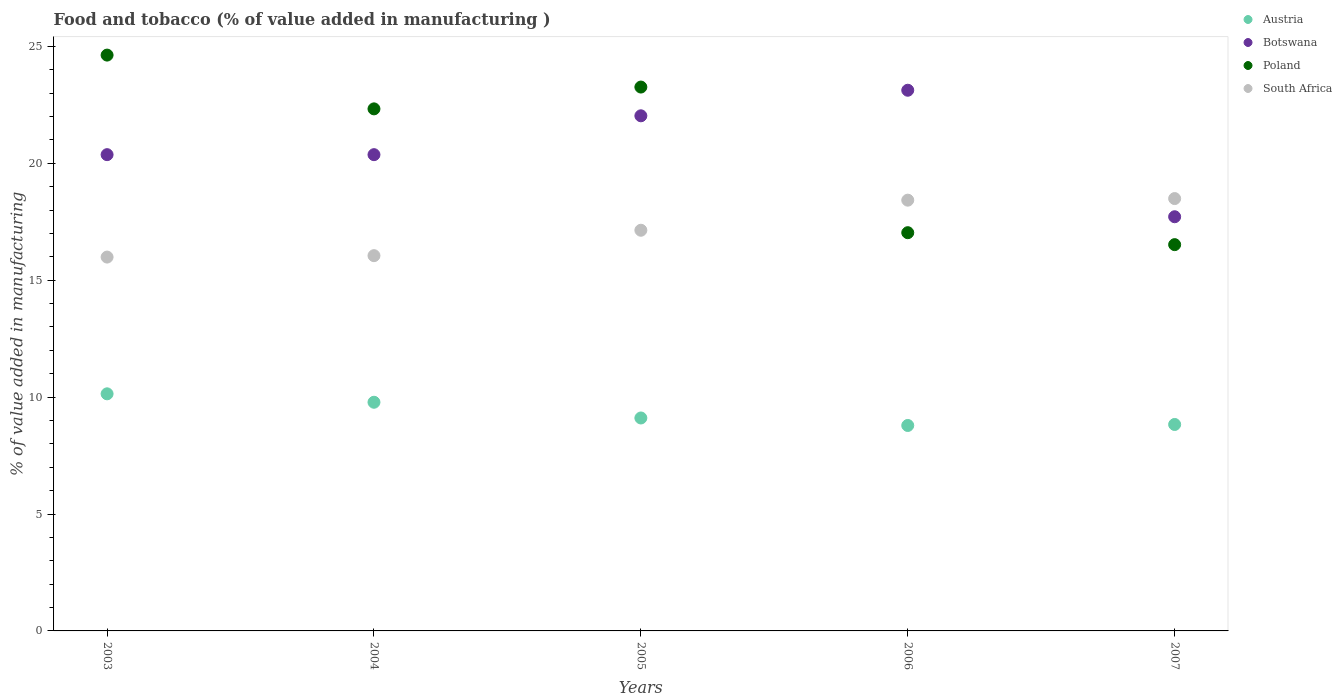How many different coloured dotlines are there?
Make the answer very short. 4. Is the number of dotlines equal to the number of legend labels?
Provide a succinct answer. Yes. What is the value added in manufacturing food and tobacco in Austria in 2004?
Provide a succinct answer. 9.78. Across all years, what is the maximum value added in manufacturing food and tobacco in Austria?
Your answer should be very brief. 10.14. Across all years, what is the minimum value added in manufacturing food and tobacco in Austria?
Keep it short and to the point. 8.79. In which year was the value added in manufacturing food and tobacco in Botswana maximum?
Offer a very short reply. 2006. What is the total value added in manufacturing food and tobacco in Botswana in the graph?
Provide a short and direct response. 103.61. What is the difference between the value added in manufacturing food and tobacco in Botswana in 2004 and that in 2007?
Your answer should be very brief. 2.66. What is the difference between the value added in manufacturing food and tobacco in Poland in 2006 and the value added in manufacturing food and tobacco in South Africa in 2007?
Make the answer very short. -1.46. What is the average value added in manufacturing food and tobacco in Austria per year?
Offer a very short reply. 9.33. In the year 2005, what is the difference between the value added in manufacturing food and tobacco in South Africa and value added in manufacturing food and tobacco in Austria?
Your response must be concise. 8.03. In how many years, is the value added in manufacturing food and tobacco in Austria greater than 15 %?
Provide a succinct answer. 0. What is the ratio of the value added in manufacturing food and tobacco in Austria in 2005 to that in 2006?
Provide a succinct answer. 1.04. Is the value added in manufacturing food and tobacco in Poland in 2006 less than that in 2007?
Give a very brief answer. No. Is the difference between the value added in manufacturing food and tobacco in South Africa in 2004 and 2005 greater than the difference between the value added in manufacturing food and tobacco in Austria in 2004 and 2005?
Ensure brevity in your answer.  No. What is the difference between the highest and the second highest value added in manufacturing food and tobacco in Poland?
Offer a terse response. 1.37. What is the difference between the highest and the lowest value added in manufacturing food and tobacco in South Africa?
Your answer should be very brief. 2.5. Is the sum of the value added in manufacturing food and tobacco in Botswana in 2005 and 2007 greater than the maximum value added in manufacturing food and tobacco in South Africa across all years?
Give a very brief answer. Yes. Is it the case that in every year, the sum of the value added in manufacturing food and tobacco in Botswana and value added in manufacturing food and tobacco in Austria  is greater than the value added in manufacturing food and tobacco in Poland?
Offer a very short reply. Yes. Does the value added in manufacturing food and tobacco in Poland monotonically increase over the years?
Offer a terse response. No. Is the value added in manufacturing food and tobacco in Botswana strictly greater than the value added in manufacturing food and tobacco in Poland over the years?
Provide a succinct answer. No. How many dotlines are there?
Provide a short and direct response. 4. How many years are there in the graph?
Your answer should be very brief. 5. What is the difference between two consecutive major ticks on the Y-axis?
Make the answer very short. 5. Does the graph contain any zero values?
Offer a terse response. No. Does the graph contain grids?
Ensure brevity in your answer.  No. Where does the legend appear in the graph?
Keep it short and to the point. Top right. How many legend labels are there?
Your answer should be compact. 4. What is the title of the graph?
Provide a succinct answer. Food and tobacco (% of value added in manufacturing ). Does "Equatorial Guinea" appear as one of the legend labels in the graph?
Your response must be concise. No. What is the label or title of the Y-axis?
Provide a succinct answer. % of value added in manufacturing. What is the % of value added in manufacturing in Austria in 2003?
Your answer should be very brief. 10.14. What is the % of value added in manufacturing of Botswana in 2003?
Ensure brevity in your answer.  20.37. What is the % of value added in manufacturing of Poland in 2003?
Make the answer very short. 24.63. What is the % of value added in manufacturing of South Africa in 2003?
Provide a succinct answer. 15.99. What is the % of value added in manufacturing in Austria in 2004?
Offer a terse response. 9.78. What is the % of value added in manufacturing in Botswana in 2004?
Your answer should be compact. 20.37. What is the % of value added in manufacturing in Poland in 2004?
Offer a very short reply. 22.33. What is the % of value added in manufacturing in South Africa in 2004?
Ensure brevity in your answer.  16.05. What is the % of value added in manufacturing in Austria in 2005?
Offer a terse response. 9.11. What is the % of value added in manufacturing in Botswana in 2005?
Offer a very short reply. 22.03. What is the % of value added in manufacturing of Poland in 2005?
Your answer should be very brief. 23.26. What is the % of value added in manufacturing in South Africa in 2005?
Make the answer very short. 17.14. What is the % of value added in manufacturing of Austria in 2006?
Your answer should be compact. 8.79. What is the % of value added in manufacturing of Botswana in 2006?
Offer a terse response. 23.13. What is the % of value added in manufacturing in Poland in 2006?
Offer a very short reply. 17.03. What is the % of value added in manufacturing in South Africa in 2006?
Provide a succinct answer. 18.42. What is the % of value added in manufacturing in Austria in 2007?
Provide a succinct answer. 8.83. What is the % of value added in manufacturing in Botswana in 2007?
Offer a very short reply. 17.72. What is the % of value added in manufacturing in Poland in 2007?
Offer a terse response. 16.52. What is the % of value added in manufacturing of South Africa in 2007?
Your answer should be compact. 18.49. Across all years, what is the maximum % of value added in manufacturing of Austria?
Keep it short and to the point. 10.14. Across all years, what is the maximum % of value added in manufacturing in Botswana?
Offer a terse response. 23.13. Across all years, what is the maximum % of value added in manufacturing of Poland?
Your response must be concise. 24.63. Across all years, what is the maximum % of value added in manufacturing of South Africa?
Your response must be concise. 18.49. Across all years, what is the minimum % of value added in manufacturing of Austria?
Keep it short and to the point. 8.79. Across all years, what is the minimum % of value added in manufacturing of Botswana?
Keep it short and to the point. 17.72. Across all years, what is the minimum % of value added in manufacturing in Poland?
Offer a terse response. 16.52. Across all years, what is the minimum % of value added in manufacturing in South Africa?
Provide a succinct answer. 15.99. What is the total % of value added in manufacturing in Austria in the graph?
Keep it short and to the point. 46.65. What is the total % of value added in manufacturing of Botswana in the graph?
Ensure brevity in your answer.  103.61. What is the total % of value added in manufacturing of Poland in the graph?
Give a very brief answer. 103.78. What is the total % of value added in manufacturing of South Africa in the graph?
Provide a succinct answer. 86.09. What is the difference between the % of value added in manufacturing in Austria in 2003 and that in 2004?
Provide a short and direct response. 0.36. What is the difference between the % of value added in manufacturing in Botswana in 2003 and that in 2004?
Give a very brief answer. 0. What is the difference between the % of value added in manufacturing in South Africa in 2003 and that in 2004?
Keep it short and to the point. -0.06. What is the difference between the % of value added in manufacturing in Austria in 2003 and that in 2005?
Your answer should be very brief. 1.03. What is the difference between the % of value added in manufacturing of Botswana in 2003 and that in 2005?
Provide a short and direct response. -1.66. What is the difference between the % of value added in manufacturing of Poland in 2003 and that in 2005?
Keep it short and to the point. 1.37. What is the difference between the % of value added in manufacturing of South Africa in 2003 and that in 2005?
Your response must be concise. -1.15. What is the difference between the % of value added in manufacturing in Austria in 2003 and that in 2006?
Your answer should be very brief. 1.35. What is the difference between the % of value added in manufacturing in Botswana in 2003 and that in 2006?
Give a very brief answer. -2.76. What is the difference between the % of value added in manufacturing in Poland in 2003 and that in 2006?
Your answer should be compact. 7.6. What is the difference between the % of value added in manufacturing in South Africa in 2003 and that in 2006?
Your answer should be very brief. -2.43. What is the difference between the % of value added in manufacturing in Austria in 2003 and that in 2007?
Your answer should be very brief. 1.31. What is the difference between the % of value added in manufacturing in Botswana in 2003 and that in 2007?
Your response must be concise. 2.66. What is the difference between the % of value added in manufacturing of Poland in 2003 and that in 2007?
Your answer should be very brief. 8.11. What is the difference between the % of value added in manufacturing in South Africa in 2003 and that in 2007?
Your response must be concise. -2.5. What is the difference between the % of value added in manufacturing of Austria in 2004 and that in 2005?
Provide a succinct answer. 0.67. What is the difference between the % of value added in manufacturing of Botswana in 2004 and that in 2005?
Your response must be concise. -1.66. What is the difference between the % of value added in manufacturing in Poland in 2004 and that in 2005?
Your response must be concise. -0.93. What is the difference between the % of value added in manufacturing in South Africa in 2004 and that in 2005?
Offer a very short reply. -1.09. What is the difference between the % of value added in manufacturing of Botswana in 2004 and that in 2006?
Your answer should be compact. -2.76. What is the difference between the % of value added in manufacturing of Poland in 2004 and that in 2006?
Offer a terse response. 5.3. What is the difference between the % of value added in manufacturing in South Africa in 2004 and that in 2006?
Provide a succinct answer. -2.37. What is the difference between the % of value added in manufacturing of Austria in 2004 and that in 2007?
Offer a terse response. 0.95. What is the difference between the % of value added in manufacturing in Botswana in 2004 and that in 2007?
Give a very brief answer. 2.66. What is the difference between the % of value added in manufacturing in Poland in 2004 and that in 2007?
Provide a short and direct response. 5.81. What is the difference between the % of value added in manufacturing of South Africa in 2004 and that in 2007?
Give a very brief answer. -2.44. What is the difference between the % of value added in manufacturing of Austria in 2005 and that in 2006?
Offer a terse response. 0.32. What is the difference between the % of value added in manufacturing in Botswana in 2005 and that in 2006?
Provide a succinct answer. -1.09. What is the difference between the % of value added in manufacturing of Poland in 2005 and that in 2006?
Ensure brevity in your answer.  6.23. What is the difference between the % of value added in manufacturing in South Africa in 2005 and that in 2006?
Ensure brevity in your answer.  -1.29. What is the difference between the % of value added in manufacturing of Austria in 2005 and that in 2007?
Provide a short and direct response. 0.28. What is the difference between the % of value added in manufacturing in Botswana in 2005 and that in 2007?
Ensure brevity in your answer.  4.32. What is the difference between the % of value added in manufacturing of Poland in 2005 and that in 2007?
Provide a short and direct response. 6.74. What is the difference between the % of value added in manufacturing of South Africa in 2005 and that in 2007?
Keep it short and to the point. -1.35. What is the difference between the % of value added in manufacturing in Austria in 2006 and that in 2007?
Keep it short and to the point. -0.04. What is the difference between the % of value added in manufacturing of Botswana in 2006 and that in 2007?
Offer a very short reply. 5.41. What is the difference between the % of value added in manufacturing in Poland in 2006 and that in 2007?
Provide a short and direct response. 0.51. What is the difference between the % of value added in manufacturing of South Africa in 2006 and that in 2007?
Your answer should be very brief. -0.07. What is the difference between the % of value added in manufacturing of Austria in 2003 and the % of value added in manufacturing of Botswana in 2004?
Keep it short and to the point. -10.23. What is the difference between the % of value added in manufacturing in Austria in 2003 and the % of value added in manufacturing in Poland in 2004?
Ensure brevity in your answer.  -12.19. What is the difference between the % of value added in manufacturing of Austria in 2003 and the % of value added in manufacturing of South Africa in 2004?
Offer a terse response. -5.91. What is the difference between the % of value added in manufacturing of Botswana in 2003 and the % of value added in manufacturing of Poland in 2004?
Offer a very short reply. -1.96. What is the difference between the % of value added in manufacturing of Botswana in 2003 and the % of value added in manufacturing of South Africa in 2004?
Your answer should be compact. 4.32. What is the difference between the % of value added in manufacturing of Poland in 2003 and the % of value added in manufacturing of South Africa in 2004?
Provide a short and direct response. 8.58. What is the difference between the % of value added in manufacturing in Austria in 2003 and the % of value added in manufacturing in Botswana in 2005?
Offer a very short reply. -11.89. What is the difference between the % of value added in manufacturing in Austria in 2003 and the % of value added in manufacturing in Poland in 2005?
Provide a short and direct response. -13.12. What is the difference between the % of value added in manufacturing in Austria in 2003 and the % of value added in manufacturing in South Africa in 2005?
Provide a short and direct response. -7. What is the difference between the % of value added in manufacturing of Botswana in 2003 and the % of value added in manufacturing of Poland in 2005?
Your answer should be compact. -2.89. What is the difference between the % of value added in manufacturing in Botswana in 2003 and the % of value added in manufacturing in South Africa in 2005?
Make the answer very short. 3.23. What is the difference between the % of value added in manufacturing in Poland in 2003 and the % of value added in manufacturing in South Africa in 2005?
Ensure brevity in your answer.  7.49. What is the difference between the % of value added in manufacturing of Austria in 2003 and the % of value added in manufacturing of Botswana in 2006?
Offer a terse response. -12.98. What is the difference between the % of value added in manufacturing in Austria in 2003 and the % of value added in manufacturing in Poland in 2006?
Provide a succinct answer. -6.89. What is the difference between the % of value added in manufacturing of Austria in 2003 and the % of value added in manufacturing of South Africa in 2006?
Provide a succinct answer. -8.28. What is the difference between the % of value added in manufacturing of Botswana in 2003 and the % of value added in manufacturing of Poland in 2006?
Provide a short and direct response. 3.34. What is the difference between the % of value added in manufacturing of Botswana in 2003 and the % of value added in manufacturing of South Africa in 2006?
Your response must be concise. 1.95. What is the difference between the % of value added in manufacturing of Poland in 2003 and the % of value added in manufacturing of South Africa in 2006?
Give a very brief answer. 6.2. What is the difference between the % of value added in manufacturing in Austria in 2003 and the % of value added in manufacturing in Botswana in 2007?
Make the answer very short. -7.57. What is the difference between the % of value added in manufacturing of Austria in 2003 and the % of value added in manufacturing of Poland in 2007?
Keep it short and to the point. -6.38. What is the difference between the % of value added in manufacturing in Austria in 2003 and the % of value added in manufacturing in South Africa in 2007?
Provide a succinct answer. -8.35. What is the difference between the % of value added in manufacturing in Botswana in 2003 and the % of value added in manufacturing in Poland in 2007?
Give a very brief answer. 3.85. What is the difference between the % of value added in manufacturing in Botswana in 2003 and the % of value added in manufacturing in South Africa in 2007?
Keep it short and to the point. 1.88. What is the difference between the % of value added in manufacturing in Poland in 2003 and the % of value added in manufacturing in South Africa in 2007?
Provide a short and direct response. 6.14. What is the difference between the % of value added in manufacturing of Austria in 2004 and the % of value added in manufacturing of Botswana in 2005?
Provide a succinct answer. -12.25. What is the difference between the % of value added in manufacturing of Austria in 2004 and the % of value added in manufacturing of Poland in 2005?
Offer a terse response. -13.48. What is the difference between the % of value added in manufacturing in Austria in 2004 and the % of value added in manufacturing in South Africa in 2005?
Ensure brevity in your answer.  -7.36. What is the difference between the % of value added in manufacturing in Botswana in 2004 and the % of value added in manufacturing in Poland in 2005?
Provide a short and direct response. -2.89. What is the difference between the % of value added in manufacturing in Botswana in 2004 and the % of value added in manufacturing in South Africa in 2005?
Your answer should be compact. 3.23. What is the difference between the % of value added in manufacturing of Poland in 2004 and the % of value added in manufacturing of South Africa in 2005?
Keep it short and to the point. 5.19. What is the difference between the % of value added in manufacturing of Austria in 2004 and the % of value added in manufacturing of Botswana in 2006?
Provide a succinct answer. -13.35. What is the difference between the % of value added in manufacturing in Austria in 2004 and the % of value added in manufacturing in Poland in 2006?
Give a very brief answer. -7.25. What is the difference between the % of value added in manufacturing of Austria in 2004 and the % of value added in manufacturing of South Africa in 2006?
Keep it short and to the point. -8.64. What is the difference between the % of value added in manufacturing in Botswana in 2004 and the % of value added in manufacturing in Poland in 2006?
Keep it short and to the point. 3.34. What is the difference between the % of value added in manufacturing of Botswana in 2004 and the % of value added in manufacturing of South Africa in 2006?
Your answer should be very brief. 1.95. What is the difference between the % of value added in manufacturing of Poland in 2004 and the % of value added in manufacturing of South Africa in 2006?
Offer a terse response. 3.9. What is the difference between the % of value added in manufacturing of Austria in 2004 and the % of value added in manufacturing of Botswana in 2007?
Your answer should be compact. -7.93. What is the difference between the % of value added in manufacturing in Austria in 2004 and the % of value added in manufacturing in Poland in 2007?
Provide a short and direct response. -6.74. What is the difference between the % of value added in manufacturing in Austria in 2004 and the % of value added in manufacturing in South Africa in 2007?
Your answer should be very brief. -8.71. What is the difference between the % of value added in manufacturing of Botswana in 2004 and the % of value added in manufacturing of Poland in 2007?
Offer a very short reply. 3.85. What is the difference between the % of value added in manufacturing in Botswana in 2004 and the % of value added in manufacturing in South Africa in 2007?
Make the answer very short. 1.88. What is the difference between the % of value added in manufacturing of Poland in 2004 and the % of value added in manufacturing of South Africa in 2007?
Provide a succinct answer. 3.84. What is the difference between the % of value added in manufacturing in Austria in 2005 and the % of value added in manufacturing in Botswana in 2006?
Offer a very short reply. -14.02. What is the difference between the % of value added in manufacturing of Austria in 2005 and the % of value added in manufacturing of Poland in 2006?
Keep it short and to the point. -7.92. What is the difference between the % of value added in manufacturing in Austria in 2005 and the % of value added in manufacturing in South Africa in 2006?
Provide a short and direct response. -9.32. What is the difference between the % of value added in manufacturing in Botswana in 2005 and the % of value added in manufacturing in Poland in 2006?
Your response must be concise. 5. What is the difference between the % of value added in manufacturing in Botswana in 2005 and the % of value added in manufacturing in South Africa in 2006?
Ensure brevity in your answer.  3.61. What is the difference between the % of value added in manufacturing in Poland in 2005 and the % of value added in manufacturing in South Africa in 2006?
Provide a short and direct response. 4.84. What is the difference between the % of value added in manufacturing in Austria in 2005 and the % of value added in manufacturing in Botswana in 2007?
Ensure brevity in your answer.  -8.61. What is the difference between the % of value added in manufacturing of Austria in 2005 and the % of value added in manufacturing of Poland in 2007?
Provide a short and direct response. -7.41. What is the difference between the % of value added in manufacturing of Austria in 2005 and the % of value added in manufacturing of South Africa in 2007?
Give a very brief answer. -9.38. What is the difference between the % of value added in manufacturing of Botswana in 2005 and the % of value added in manufacturing of Poland in 2007?
Offer a terse response. 5.51. What is the difference between the % of value added in manufacturing in Botswana in 2005 and the % of value added in manufacturing in South Africa in 2007?
Make the answer very short. 3.54. What is the difference between the % of value added in manufacturing of Poland in 2005 and the % of value added in manufacturing of South Africa in 2007?
Offer a very short reply. 4.77. What is the difference between the % of value added in manufacturing in Austria in 2006 and the % of value added in manufacturing in Botswana in 2007?
Ensure brevity in your answer.  -8.93. What is the difference between the % of value added in manufacturing in Austria in 2006 and the % of value added in manufacturing in Poland in 2007?
Your response must be concise. -7.73. What is the difference between the % of value added in manufacturing in Austria in 2006 and the % of value added in manufacturing in South Africa in 2007?
Your answer should be very brief. -9.71. What is the difference between the % of value added in manufacturing in Botswana in 2006 and the % of value added in manufacturing in Poland in 2007?
Provide a succinct answer. 6.6. What is the difference between the % of value added in manufacturing of Botswana in 2006 and the % of value added in manufacturing of South Africa in 2007?
Provide a short and direct response. 4.63. What is the difference between the % of value added in manufacturing in Poland in 2006 and the % of value added in manufacturing in South Africa in 2007?
Your answer should be very brief. -1.46. What is the average % of value added in manufacturing of Austria per year?
Your answer should be compact. 9.33. What is the average % of value added in manufacturing of Botswana per year?
Give a very brief answer. 20.72. What is the average % of value added in manufacturing in Poland per year?
Provide a short and direct response. 20.75. What is the average % of value added in manufacturing of South Africa per year?
Give a very brief answer. 17.22. In the year 2003, what is the difference between the % of value added in manufacturing of Austria and % of value added in manufacturing of Botswana?
Your response must be concise. -10.23. In the year 2003, what is the difference between the % of value added in manufacturing in Austria and % of value added in manufacturing in Poland?
Make the answer very short. -14.49. In the year 2003, what is the difference between the % of value added in manufacturing of Austria and % of value added in manufacturing of South Africa?
Provide a succinct answer. -5.85. In the year 2003, what is the difference between the % of value added in manufacturing in Botswana and % of value added in manufacturing in Poland?
Provide a succinct answer. -4.26. In the year 2003, what is the difference between the % of value added in manufacturing of Botswana and % of value added in manufacturing of South Africa?
Ensure brevity in your answer.  4.38. In the year 2003, what is the difference between the % of value added in manufacturing in Poland and % of value added in manufacturing in South Africa?
Your answer should be very brief. 8.64. In the year 2004, what is the difference between the % of value added in manufacturing of Austria and % of value added in manufacturing of Botswana?
Keep it short and to the point. -10.59. In the year 2004, what is the difference between the % of value added in manufacturing of Austria and % of value added in manufacturing of Poland?
Offer a very short reply. -12.55. In the year 2004, what is the difference between the % of value added in manufacturing of Austria and % of value added in manufacturing of South Africa?
Offer a very short reply. -6.27. In the year 2004, what is the difference between the % of value added in manufacturing in Botswana and % of value added in manufacturing in Poland?
Offer a very short reply. -1.96. In the year 2004, what is the difference between the % of value added in manufacturing in Botswana and % of value added in manufacturing in South Africa?
Make the answer very short. 4.32. In the year 2004, what is the difference between the % of value added in manufacturing of Poland and % of value added in manufacturing of South Africa?
Give a very brief answer. 6.28. In the year 2005, what is the difference between the % of value added in manufacturing of Austria and % of value added in manufacturing of Botswana?
Keep it short and to the point. -12.92. In the year 2005, what is the difference between the % of value added in manufacturing of Austria and % of value added in manufacturing of Poland?
Your answer should be very brief. -14.15. In the year 2005, what is the difference between the % of value added in manufacturing of Austria and % of value added in manufacturing of South Africa?
Keep it short and to the point. -8.03. In the year 2005, what is the difference between the % of value added in manufacturing in Botswana and % of value added in manufacturing in Poland?
Provide a succinct answer. -1.23. In the year 2005, what is the difference between the % of value added in manufacturing of Botswana and % of value added in manufacturing of South Africa?
Provide a short and direct response. 4.9. In the year 2005, what is the difference between the % of value added in manufacturing of Poland and % of value added in manufacturing of South Africa?
Give a very brief answer. 6.12. In the year 2006, what is the difference between the % of value added in manufacturing in Austria and % of value added in manufacturing in Botswana?
Keep it short and to the point. -14.34. In the year 2006, what is the difference between the % of value added in manufacturing of Austria and % of value added in manufacturing of Poland?
Keep it short and to the point. -8.25. In the year 2006, what is the difference between the % of value added in manufacturing of Austria and % of value added in manufacturing of South Africa?
Your response must be concise. -9.64. In the year 2006, what is the difference between the % of value added in manufacturing in Botswana and % of value added in manufacturing in Poland?
Ensure brevity in your answer.  6.09. In the year 2006, what is the difference between the % of value added in manufacturing of Botswana and % of value added in manufacturing of South Africa?
Ensure brevity in your answer.  4.7. In the year 2006, what is the difference between the % of value added in manufacturing of Poland and % of value added in manufacturing of South Africa?
Ensure brevity in your answer.  -1.39. In the year 2007, what is the difference between the % of value added in manufacturing of Austria and % of value added in manufacturing of Botswana?
Make the answer very short. -8.88. In the year 2007, what is the difference between the % of value added in manufacturing in Austria and % of value added in manufacturing in Poland?
Ensure brevity in your answer.  -7.69. In the year 2007, what is the difference between the % of value added in manufacturing in Austria and % of value added in manufacturing in South Africa?
Offer a very short reply. -9.66. In the year 2007, what is the difference between the % of value added in manufacturing of Botswana and % of value added in manufacturing of Poland?
Provide a succinct answer. 1.19. In the year 2007, what is the difference between the % of value added in manufacturing of Botswana and % of value added in manufacturing of South Africa?
Your response must be concise. -0.78. In the year 2007, what is the difference between the % of value added in manufacturing of Poland and % of value added in manufacturing of South Africa?
Offer a terse response. -1.97. What is the ratio of the % of value added in manufacturing of Austria in 2003 to that in 2004?
Your answer should be compact. 1.04. What is the ratio of the % of value added in manufacturing in Botswana in 2003 to that in 2004?
Ensure brevity in your answer.  1. What is the ratio of the % of value added in manufacturing in Poland in 2003 to that in 2004?
Ensure brevity in your answer.  1.1. What is the ratio of the % of value added in manufacturing in Austria in 2003 to that in 2005?
Ensure brevity in your answer.  1.11. What is the ratio of the % of value added in manufacturing in Botswana in 2003 to that in 2005?
Your answer should be very brief. 0.92. What is the ratio of the % of value added in manufacturing of Poland in 2003 to that in 2005?
Your answer should be compact. 1.06. What is the ratio of the % of value added in manufacturing in South Africa in 2003 to that in 2005?
Your response must be concise. 0.93. What is the ratio of the % of value added in manufacturing in Austria in 2003 to that in 2006?
Your response must be concise. 1.15. What is the ratio of the % of value added in manufacturing of Botswana in 2003 to that in 2006?
Provide a succinct answer. 0.88. What is the ratio of the % of value added in manufacturing of Poland in 2003 to that in 2006?
Keep it short and to the point. 1.45. What is the ratio of the % of value added in manufacturing in South Africa in 2003 to that in 2006?
Ensure brevity in your answer.  0.87. What is the ratio of the % of value added in manufacturing of Austria in 2003 to that in 2007?
Your answer should be very brief. 1.15. What is the ratio of the % of value added in manufacturing in Botswana in 2003 to that in 2007?
Your response must be concise. 1.15. What is the ratio of the % of value added in manufacturing of Poland in 2003 to that in 2007?
Offer a very short reply. 1.49. What is the ratio of the % of value added in manufacturing in South Africa in 2003 to that in 2007?
Offer a terse response. 0.86. What is the ratio of the % of value added in manufacturing in Austria in 2004 to that in 2005?
Your answer should be compact. 1.07. What is the ratio of the % of value added in manufacturing of Botswana in 2004 to that in 2005?
Your answer should be compact. 0.92. What is the ratio of the % of value added in manufacturing in Poland in 2004 to that in 2005?
Your answer should be very brief. 0.96. What is the ratio of the % of value added in manufacturing in South Africa in 2004 to that in 2005?
Your answer should be very brief. 0.94. What is the ratio of the % of value added in manufacturing of Austria in 2004 to that in 2006?
Your answer should be very brief. 1.11. What is the ratio of the % of value added in manufacturing of Botswana in 2004 to that in 2006?
Your response must be concise. 0.88. What is the ratio of the % of value added in manufacturing in Poland in 2004 to that in 2006?
Keep it short and to the point. 1.31. What is the ratio of the % of value added in manufacturing in South Africa in 2004 to that in 2006?
Offer a very short reply. 0.87. What is the ratio of the % of value added in manufacturing in Austria in 2004 to that in 2007?
Offer a very short reply. 1.11. What is the ratio of the % of value added in manufacturing in Botswana in 2004 to that in 2007?
Make the answer very short. 1.15. What is the ratio of the % of value added in manufacturing in Poland in 2004 to that in 2007?
Offer a terse response. 1.35. What is the ratio of the % of value added in manufacturing in South Africa in 2004 to that in 2007?
Your response must be concise. 0.87. What is the ratio of the % of value added in manufacturing of Austria in 2005 to that in 2006?
Keep it short and to the point. 1.04. What is the ratio of the % of value added in manufacturing of Botswana in 2005 to that in 2006?
Ensure brevity in your answer.  0.95. What is the ratio of the % of value added in manufacturing of Poland in 2005 to that in 2006?
Your response must be concise. 1.37. What is the ratio of the % of value added in manufacturing of South Africa in 2005 to that in 2006?
Offer a very short reply. 0.93. What is the ratio of the % of value added in manufacturing in Austria in 2005 to that in 2007?
Offer a terse response. 1.03. What is the ratio of the % of value added in manufacturing in Botswana in 2005 to that in 2007?
Ensure brevity in your answer.  1.24. What is the ratio of the % of value added in manufacturing in Poland in 2005 to that in 2007?
Your answer should be compact. 1.41. What is the ratio of the % of value added in manufacturing of South Africa in 2005 to that in 2007?
Give a very brief answer. 0.93. What is the ratio of the % of value added in manufacturing of Austria in 2006 to that in 2007?
Provide a succinct answer. 1. What is the ratio of the % of value added in manufacturing of Botswana in 2006 to that in 2007?
Ensure brevity in your answer.  1.31. What is the ratio of the % of value added in manufacturing of Poland in 2006 to that in 2007?
Offer a very short reply. 1.03. What is the difference between the highest and the second highest % of value added in manufacturing of Austria?
Offer a very short reply. 0.36. What is the difference between the highest and the second highest % of value added in manufacturing of Botswana?
Make the answer very short. 1.09. What is the difference between the highest and the second highest % of value added in manufacturing in Poland?
Your answer should be compact. 1.37. What is the difference between the highest and the second highest % of value added in manufacturing of South Africa?
Make the answer very short. 0.07. What is the difference between the highest and the lowest % of value added in manufacturing of Austria?
Your answer should be very brief. 1.35. What is the difference between the highest and the lowest % of value added in manufacturing of Botswana?
Your answer should be compact. 5.41. What is the difference between the highest and the lowest % of value added in manufacturing in Poland?
Ensure brevity in your answer.  8.11. What is the difference between the highest and the lowest % of value added in manufacturing in South Africa?
Your answer should be very brief. 2.5. 